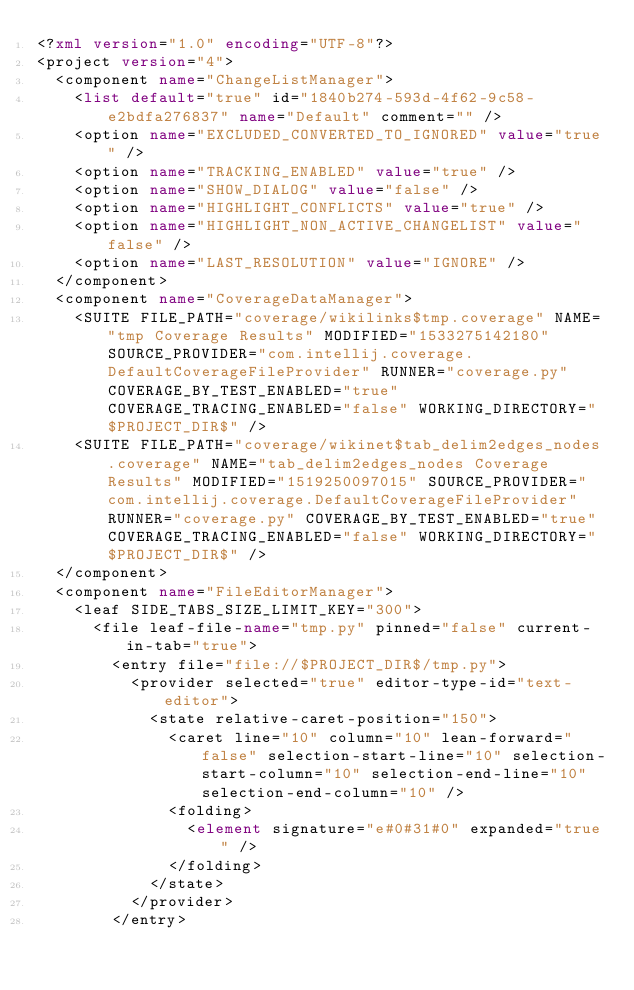Convert code to text. <code><loc_0><loc_0><loc_500><loc_500><_XML_><?xml version="1.0" encoding="UTF-8"?>
<project version="4">
  <component name="ChangeListManager">
    <list default="true" id="1840b274-593d-4f62-9c58-e2bdfa276837" name="Default" comment="" />
    <option name="EXCLUDED_CONVERTED_TO_IGNORED" value="true" />
    <option name="TRACKING_ENABLED" value="true" />
    <option name="SHOW_DIALOG" value="false" />
    <option name="HIGHLIGHT_CONFLICTS" value="true" />
    <option name="HIGHLIGHT_NON_ACTIVE_CHANGELIST" value="false" />
    <option name="LAST_RESOLUTION" value="IGNORE" />
  </component>
  <component name="CoverageDataManager">
    <SUITE FILE_PATH="coverage/wikilinks$tmp.coverage" NAME="tmp Coverage Results" MODIFIED="1533275142180" SOURCE_PROVIDER="com.intellij.coverage.DefaultCoverageFileProvider" RUNNER="coverage.py" COVERAGE_BY_TEST_ENABLED="true" COVERAGE_TRACING_ENABLED="false" WORKING_DIRECTORY="$PROJECT_DIR$" />
    <SUITE FILE_PATH="coverage/wikinet$tab_delim2edges_nodes.coverage" NAME="tab_delim2edges_nodes Coverage Results" MODIFIED="1519250097015" SOURCE_PROVIDER="com.intellij.coverage.DefaultCoverageFileProvider" RUNNER="coverage.py" COVERAGE_BY_TEST_ENABLED="true" COVERAGE_TRACING_ENABLED="false" WORKING_DIRECTORY="$PROJECT_DIR$" />
  </component>
  <component name="FileEditorManager">
    <leaf SIDE_TABS_SIZE_LIMIT_KEY="300">
      <file leaf-file-name="tmp.py" pinned="false" current-in-tab="true">
        <entry file="file://$PROJECT_DIR$/tmp.py">
          <provider selected="true" editor-type-id="text-editor">
            <state relative-caret-position="150">
              <caret line="10" column="10" lean-forward="false" selection-start-line="10" selection-start-column="10" selection-end-line="10" selection-end-column="10" />
              <folding>
                <element signature="e#0#31#0" expanded="true" />
              </folding>
            </state>
          </provider>
        </entry></code> 